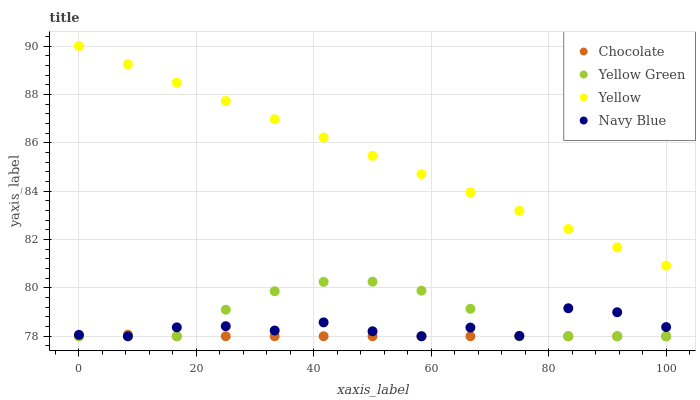Does Chocolate have the minimum area under the curve?
Answer yes or no. Yes. Does Yellow have the maximum area under the curve?
Answer yes or no. Yes. Does Yellow Green have the minimum area under the curve?
Answer yes or no. No. Does Yellow Green have the maximum area under the curve?
Answer yes or no. No. Is Yellow the smoothest?
Answer yes or no. Yes. Is Navy Blue the roughest?
Answer yes or no. Yes. Is Yellow Green the smoothest?
Answer yes or no. No. Is Yellow Green the roughest?
Answer yes or no. No. Does Navy Blue have the lowest value?
Answer yes or no. Yes. Does Yellow have the lowest value?
Answer yes or no. No. Does Yellow have the highest value?
Answer yes or no. Yes. Does Yellow Green have the highest value?
Answer yes or no. No. Is Chocolate less than Yellow?
Answer yes or no. Yes. Is Yellow greater than Chocolate?
Answer yes or no. Yes. Does Yellow Green intersect Chocolate?
Answer yes or no. Yes. Is Yellow Green less than Chocolate?
Answer yes or no. No. Is Yellow Green greater than Chocolate?
Answer yes or no. No. Does Chocolate intersect Yellow?
Answer yes or no. No. 